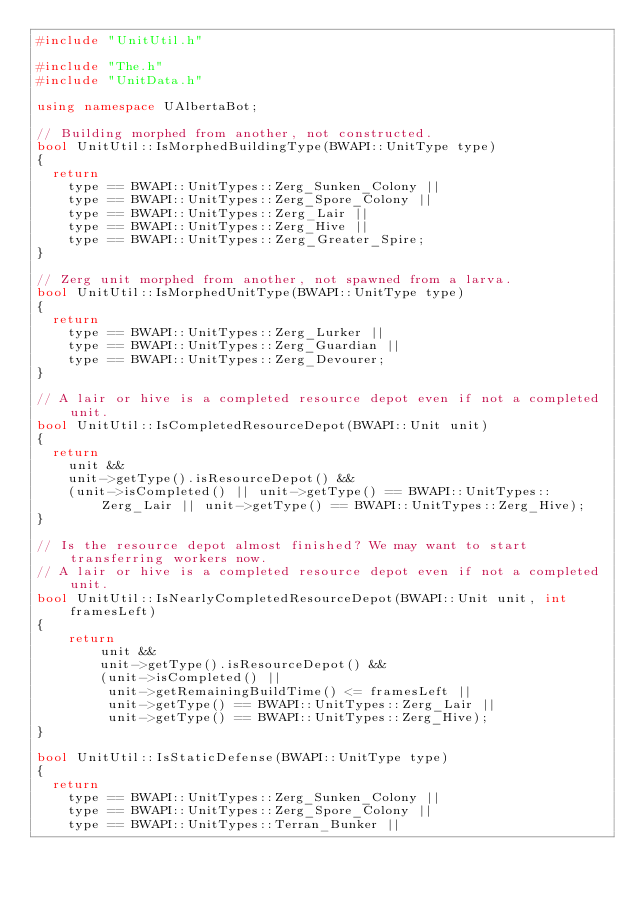<code> <loc_0><loc_0><loc_500><loc_500><_C++_>#include "UnitUtil.h"

#include "The.h"
#include "UnitData.h"

using namespace UAlbertaBot;

// Building morphed from another, not constructed.
bool UnitUtil::IsMorphedBuildingType(BWAPI::UnitType type)
{
	return
		type == BWAPI::UnitTypes::Zerg_Sunken_Colony ||
		type == BWAPI::UnitTypes::Zerg_Spore_Colony ||
		type == BWAPI::UnitTypes::Zerg_Lair ||
		type == BWAPI::UnitTypes::Zerg_Hive ||
		type == BWAPI::UnitTypes::Zerg_Greater_Spire;
}

// Zerg unit morphed from another, not spawned from a larva.
bool UnitUtil::IsMorphedUnitType(BWAPI::UnitType type)
{
	return
		type == BWAPI::UnitTypes::Zerg_Lurker ||
		type == BWAPI::UnitTypes::Zerg_Guardian ||
		type == BWAPI::UnitTypes::Zerg_Devourer;
}

// A lair or hive is a completed resource depot even if not a completed unit.
bool UnitUtil::IsCompletedResourceDepot(BWAPI::Unit unit)
{
	return
		unit &&
		unit->getType().isResourceDepot() &&
		(unit->isCompleted() || unit->getType() == BWAPI::UnitTypes::Zerg_Lair || unit->getType() == BWAPI::UnitTypes::Zerg_Hive);
}

// Is the resource depot almost finished? We may want to start transferring workers now.
// A lair or hive is a completed resource depot even if not a completed unit.
bool UnitUtil::IsNearlyCompletedResourceDepot(BWAPI::Unit unit, int framesLeft)
{
    return
        unit &&
        unit->getType().isResourceDepot() &&
        (unit->isCompleted() ||
         unit->getRemainingBuildTime() <= framesLeft ||
         unit->getType() == BWAPI::UnitTypes::Zerg_Lair ||
         unit->getType() == BWAPI::UnitTypes::Zerg_Hive);
}

bool UnitUtil::IsStaticDefense(BWAPI::UnitType type)
{
	return
		type == BWAPI::UnitTypes::Zerg_Sunken_Colony ||
		type == BWAPI::UnitTypes::Zerg_Spore_Colony ||
		type == BWAPI::UnitTypes::Terran_Bunker ||</code> 